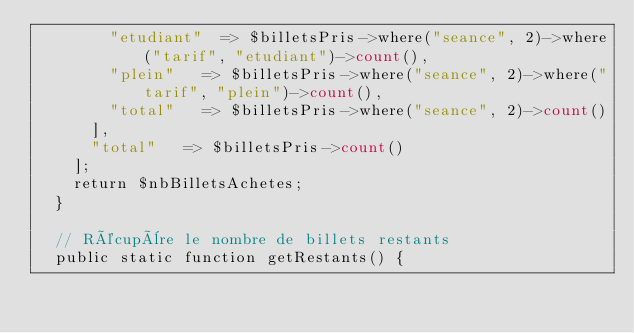Convert code to text. <code><loc_0><loc_0><loc_500><loc_500><_PHP_>				"etudiant" 	=> $billetsPris->where("seance", 2)->where("tarif", "etudiant")->count(),
				"plein" 	=> $billetsPris->where("seance", 2)->where("tarif", "plein")->count(),
				"total" 	=> $billetsPris->where("seance", 2)->count()
			],
			"total" 	=> $billetsPris->count()
		];
		return $nbBilletsAchetes;
	}

	// Récupère le nombre de billets restants
	public static function getRestants() {</code> 